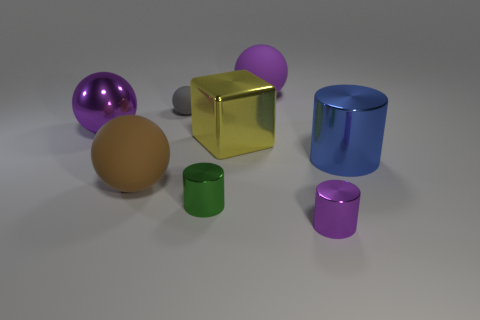Subtract all purple metal balls. How many balls are left? 3 Add 1 small yellow spheres. How many objects exist? 9 Subtract all red cylinders. How many purple balls are left? 2 Subtract all brown spheres. How many spheres are left? 3 Subtract all blocks. How many objects are left? 7 Subtract 1 brown balls. How many objects are left? 7 Subtract 1 cylinders. How many cylinders are left? 2 Subtract all red spheres. Subtract all brown cylinders. How many spheres are left? 4 Subtract all small cyan cubes. Subtract all large metal balls. How many objects are left? 7 Add 7 gray matte balls. How many gray matte balls are left? 8 